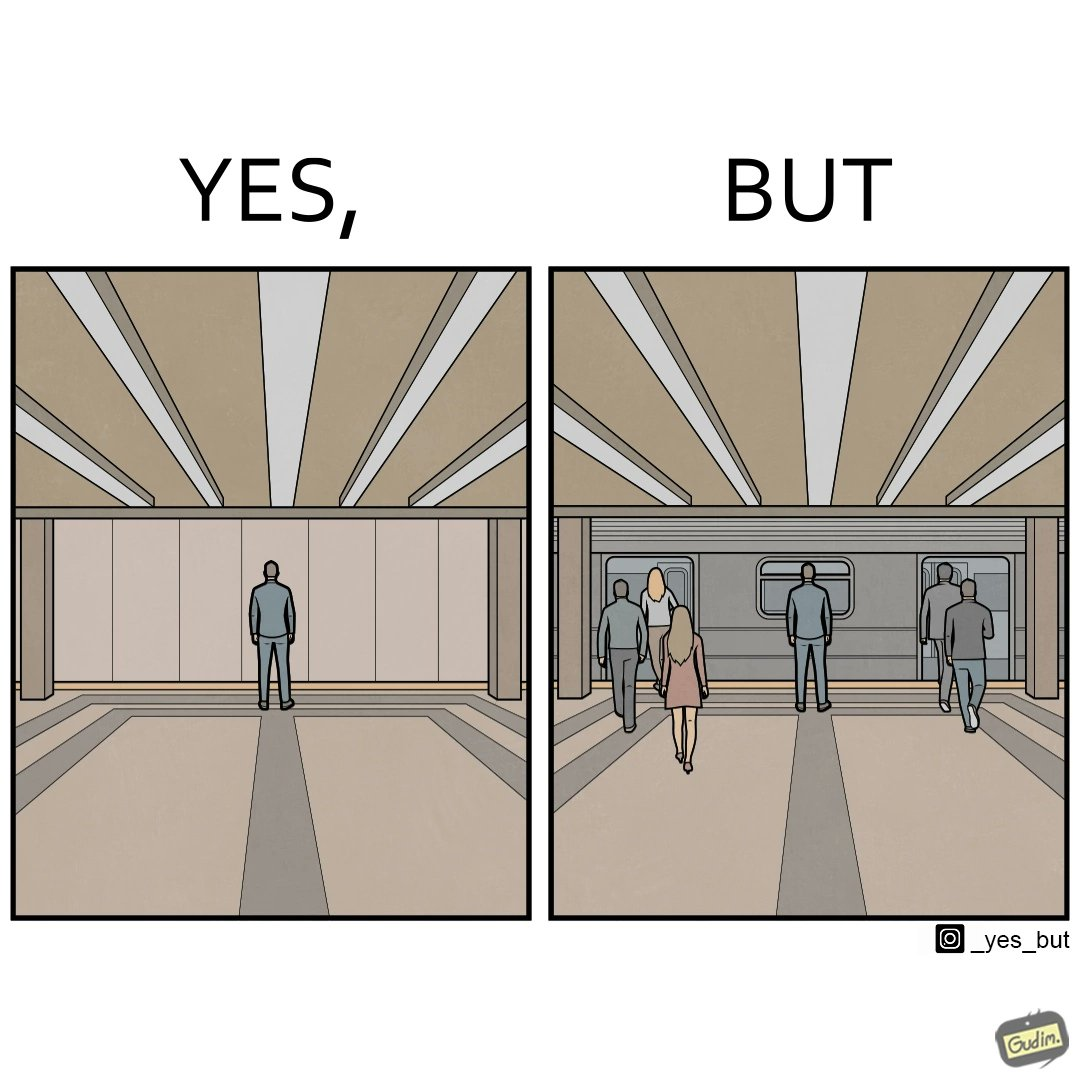What is the satirical meaning behind this image? The image is of a metro or railway station which shows that the person in left is standing in the middle at the correct place to board the train, but in the right, the doors of the train are wronglyÃÂ positioned 